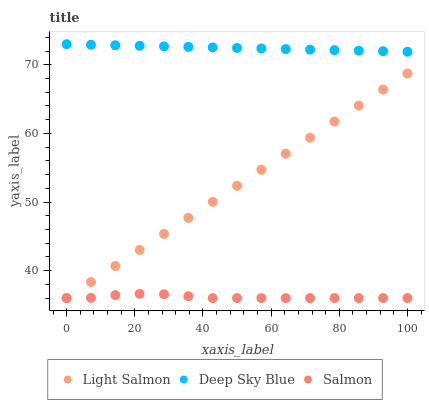Does Salmon have the minimum area under the curve?
Answer yes or no. Yes. Does Deep Sky Blue have the maximum area under the curve?
Answer yes or no. Yes. Does Deep Sky Blue have the minimum area under the curve?
Answer yes or no. No. Does Salmon have the maximum area under the curve?
Answer yes or no. No. Is Deep Sky Blue the smoothest?
Answer yes or no. Yes. Is Salmon the roughest?
Answer yes or no. Yes. Is Salmon the smoothest?
Answer yes or no. No. Is Deep Sky Blue the roughest?
Answer yes or no. No. Does Light Salmon have the lowest value?
Answer yes or no. Yes. Does Deep Sky Blue have the lowest value?
Answer yes or no. No. Does Deep Sky Blue have the highest value?
Answer yes or no. Yes. Does Salmon have the highest value?
Answer yes or no. No. Is Light Salmon less than Deep Sky Blue?
Answer yes or no. Yes. Is Deep Sky Blue greater than Light Salmon?
Answer yes or no. Yes. Does Light Salmon intersect Salmon?
Answer yes or no. Yes. Is Light Salmon less than Salmon?
Answer yes or no. No. Is Light Salmon greater than Salmon?
Answer yes or no. No. Does Light Salmon intersect Deep Sky Blue?
Answer yes or no. No. 